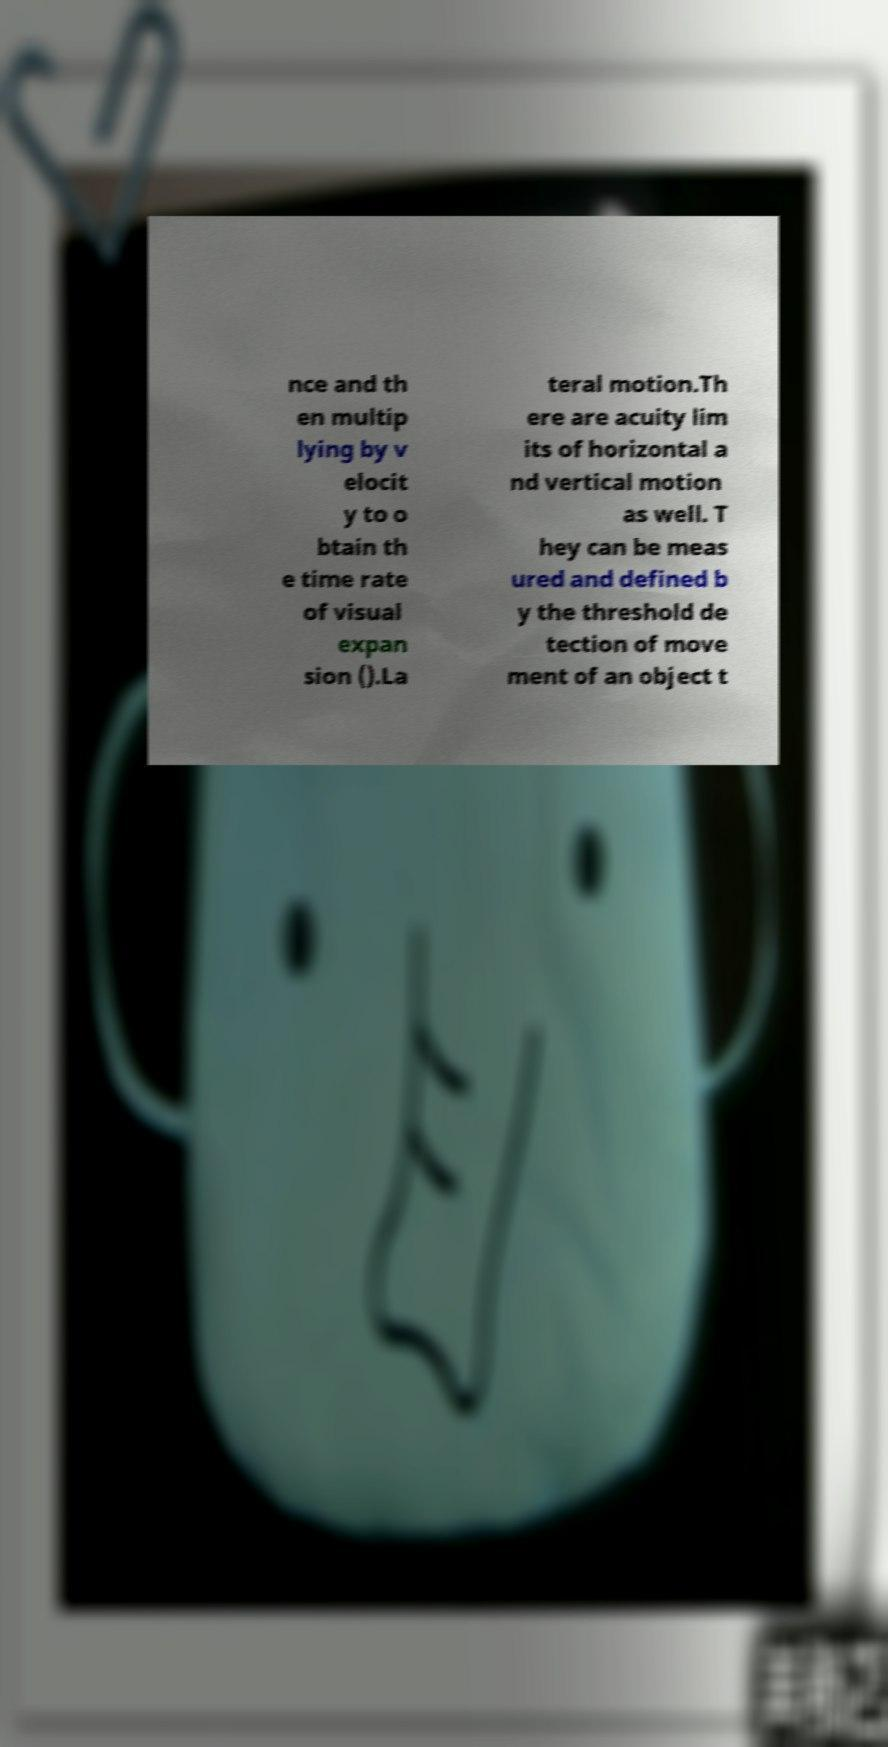I need the written content from this picture converted into text. Can you do that? nce and th en multip lying by v elocit y to o btain th e time rate of visual expan sion ().La teral motion.Th ere are acuity lim its of horizontal a nd vertical motion as well. T hey can be meas ured and defined b y the threshold de tection of move ment of an object t 